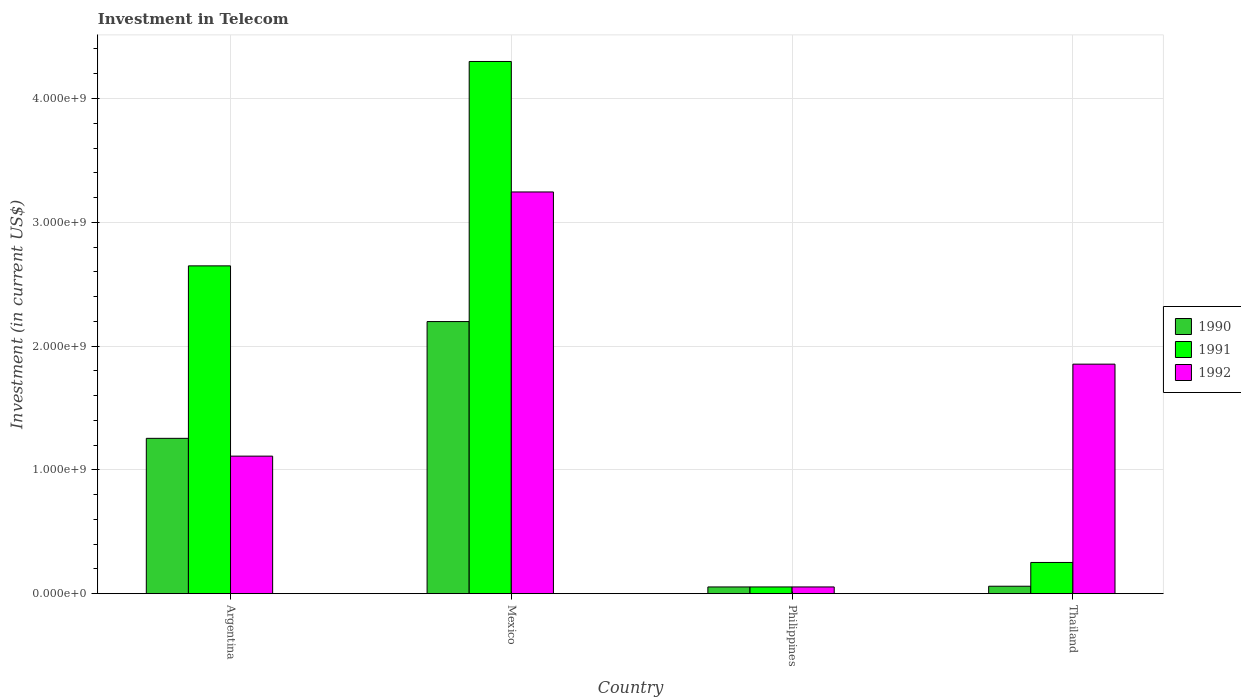How many groups of bars are there?
Your answer should be very brief. 4. Are the number of bars per tick equal to the number of legend labels?
Your response must be concise. Yes. What is the label of the 2nd group of bars from the left?
Keep it short and to the point. Mexico. What is the amount invested in telecom in 1992 in Argentina?
Keep it short and to the point. 1.11e+09. Across all countries, what is the maximum amount invested in telecom in 1990?
Your response must be concise. 2.20e+09. Across all countries, what is the minimum amount invested in telecom in 1990?
Offer a terse response. 5.42e+07. In which country was the amount invested in telecom in 1992 minimum?
Offer a very short reply. Philippines. What is the total amount invested in telecom in 1990 in the graph?
Provide a succinct answer. 3.57e+09. What is the difference between the amount invested in telecom in 1992 in Philippines and that in Thailand?
Offer a very short reply. -1.80e+09. What is the difference between the amount invested in telecom in 1991 in Thailand and the amount invested in telecom in 1990 in Argentina?
Your answer should be compact. -1.00e+09. What is the average amount invested in telecom in 1991 per country?
Provide a short and direct response. 1.81e+09. What is the difference between the amount invested in telecom of/in 1990 and amount invested in telecom of/in 1992 in Mexico?
Your answer should be very brief. -1.05e+09. What is the ratio of the amount invested in telecom in 1992 in Argentina to that in Philippines?
Your answer should be compact. 20.5. Is the amount invested in telecom in 1991 in Mexico less than that in Philippines?
Provide a short and direct response. No. What is the difference between the highest and the second highest amount invested in telecom in 1990?
Your answer should be very brief. 2.14e+09. What is the difference between the highest and the lowest amount invested in telecom in 1992?
Ensure brevity in your answer.  3.19e+09. Is the sum of the amount invested in telecom in 1992 in Mexico and Philippines greater than the maximum amount invested in telecom in 1990 across all countries?
Offer a terse response. Yes. What does the 3rd bar from the right in Thailand represents?
Offer a terse response. 1990. Is it the case that in every country, the sum of the amount invested in telecom in 1991 and amount invested in telecom in 1990 is greater than the amount invested in telecom in 1992?
Your answer should be very brief. No. Are all the bars in the graph horizontal?
Your response must be concise. No. Are the values on the major ticks of Y-axis written in scientific E-notation?
Your answer should be compact. Yes. Does the graph contain any zero values?
Give a very brief answer. No. How many legend labels are there?
Provide a succinct answer. 3. What is the title of the graph?
Your response must be concise. Investment in Telecom. Does "2000" appear as one of the legend labels in the graph?
Offer a very short reply. No. What is the label or title of the X-axis?
Give a very brief answer. Country. What is the label or title of the Y-axis?
Offer a very short reply. Investment (in current US$). What is the Investment (in current US$) of 1990 in Argentina?
Ensure brevity in your answer.  1.25e+09. What is the Investment (in current US$) in 1991 in Argentina?
Your response must be concise. 2.65e+09. What is the Investment (in current US$) of 1992 in Argentina?
Provide a short and direct response. 1.11e+09. What is the Investment (in current US$) of 1990 in Mexico?
Provide a succinct answer. 2.20e+09. What is the Investment (in current US$) of 1991 in Mexico?
Provide a short and direct response. 4.30e+09. What is the Investment (in current US$) of 1992 in Mexico?
Make the answer very short. 3.24e+09. What is the Investment (in current US$) in 1990 in Philippines?
Keep it short and to the point. 5.42e+07. What is the Investment (in current US$) of 1991 in Philippines?
Make the answer very short. 5.42e+07. What is the Investment (in current US$) in 1992 in Philippines?
Keep it short and to the point. 5.42e+07. What is the Investment (in current US$) of 1990 in Thailand?
Your answer should be very brief. 6.00e+07. What is the Investment (in current US$) in 1991 in Thailand?
Offer a very short reply. 2.52e+08. What is the Investment (in current US$) of 1992 in Thailand?
Your answer should be very brief. 1.85e+09. Across all countries, what is the maximum Investment (in current US$) in 1990?
Your response must be concise. 2.20e+09. Across all countries, what is the maximum Investment (in current US$) of 1991?
Offer a very short reply. 4.30e+09. Across all countries, what is the maximum Investment (in current US$) of 1992?
Provide a short and direct response. 3.24e+09. Across all countries, what is the minimum Investment (in current US$) of 1990?
Keep it short and to the point. 5.42e+07. Across all countries, what is the minimum Investment (in current US$) of 1991?
Provide a short and direct response. 5.42e+07. Across all countries, what is the minimum Investment (in current US$) in 1992?
Offer a very short reply. 5.42e+07. What is the total Investment (in current US$) of 1990 in the graph?
Offer a very short reply. 3.57e+09. What is the total Investment (in current US$) in 1991 in the graph?
Give a very brief answer. 7.25e+09. What is the total Investment (in current US$) in 1992 in the graph?
Keep it short and to the point. 6.26e+09. What is the difference between the Investment (in current US$) of 1990 in Argentina and that in Mexico?
Your response must be concise. -9.43e+08. What is the difference between the Investment (in current US$) in 1991 in Argentina and that in Mexico?
Your answer should be compact. -1.65e+09. What is the difference between the Investment (in current US$) of 1992 in Argentina and that in Mexico?
Ensure brevity in your answer.  -2.13e+09. What is the difference between the Investment (in current US$) in 1990 in Argentina and that in Philippines?
Your answer should be very brief. 1.20e+09. What is the difference between the Investment (in current US$) of 1991 in Argentina and that in Philippines?
Your answer should be very brief. 2.59e+09. What is the difference between the Investment (in current US$) of 1992 in Argentina and that in Philippines?
Your response must be concise. 1.06e+09. What is the difference between the Investment (in current US$) in 1990 in Argentina and that in Thailand?
Offer a very short reply. 1.19e+09. What is the difference between the Investment (in current US$) of 1991 in Argentina and that in Thailand?
Give a very brief answer. 2.40e+09. What is the difference between the Investment (in current US$) in 1992 in Argentina and that in Thailand?
Provide a succinct answer. -7.43e+08. What is the difference between the Investment (in current US$) of 1990 in Mexico and that in Philippines?
Offer a terse response. 2.14e+09. What is the difference between the Investment (in current US$) of 1991 in Mexico and that in Philippines?
Your answer should be compact. 4.24e+09. What is the difference between the Investment (in current US$) in 1992 in Mexico and that in Philippines?
Your answer should be compact. 3.19e+09. What is the difference between the Investment (in current US$) of 1990 in Mexico and that in Thailand?
Provide a short and direct response. 2.14e+09. What is the difference between the Investment (in current US$) in 1991 in Mexico and that in Thailand?
Your response must be concise. 4.05e+09. What is the difference between the Investment (in current US$) of 1992 in Mexico and that in Thailand?
Offer a very short reply. 1.39e+09. What is the difference between the Investment (in current US$) of 1990 in Philippines and that in Thailand?
Offer a very short reply. -5.80e+06. What is the difference between the Investment (in current US$) in 1991 in Philippines and that in Thailand?
Provide a succinct answer. -1.98e+08. What is the difference between the Investment (in current US$) of 1992 in Philippines and that in Thailand?
Your answer should be very brief. -1.80e+09. What is the difference between the Investment (in current US$) in 1990 in Argentina and the Investment (in current US$) in 1991 in Mexico?
Ensure brevity in your answer.  -3.04e+09. What is the difference between the Investment (in current US$) in 1990 in Argentina and the Investment (in current US$) in 1992 in Mexico?
Your answer should be very brief. -1.99e+09. What is the difference between the Investment (in current US$) in 1991 in Argentina and the Investment (in current US$) in 1992 in Mexico?
Offer a very short reply. -5.97e+08. What is the difference between the Investment (in current US$) of 1990 in Argentina and the Investment (in current US$) of 1991 in Philippines?
Give a very brief answer. 1.20e+09. What is the difference between the Investment (in current US$) in 1990 in Argentina and the Investment (in current US$) in 1992 in Philippines?
Provide a succinct answer. 1.20e+09. What is the difference between the Investment (in current US$) in 1991 in Argentina and the Investment (in current US$) in 1992 in Philippines?
Your answer should be very brief. 2.59e+09. What is the difference between the Investment (in current US$) in 1990 in Argentina and the Investment (in current US$) in 1991 in Thailand?
Keep it short and to the point. 1.00e+09. What is the difference between the Investment (in current US$) of 1990 in Argentina and the Investment (in current US$) of 1992 in Thailand?
Your answer should be very brief. -5.99e+08. What is the difference between the Investment (in current US$) in 1991 in Argentina and the Investment (in current US$) in 1992 in Thailand?
Make the answer very short. 7.94e+08. What is the difference between the Investment (in current US$) in 1990 in Mexico and the Investment (in current US$) in 1991 in Philippines?
Keep it short and to the point. 2.14e+09. What is the difference between the Investment (in current US$) of 1990 in Mexico and the Investment (in current US$) of 1992 in Philippines?
Make the answer very short. 2.14e+09. What is the difference between the Investment (in current US$) in 1991 in Mexico and the Investment (in current US$) in 1992 in Philippines?
Make the answer very short. 4.24e+09. What is the difference between the Investment (in current US$) in 1990 in Mexico and the Investment (in current US$) in 1991 in Thailand?
Make the answer very short. 1.95e+09. What is the difference between the Investment (in current US$) in 1990 in Mexico and the Investment (in current US$) in 1992 in Thailand?
Give a very brief answer. 3.44e+08. What is the difference between the Investment (in current US$) of 1991 in Mexico and the Investment (in current US$) of 1992 in Thailand?
Ensure brevity in your answer.  2.44e+09. What is the difference between the Investment (in current US$) in 1990 in Philippines and the Investment (in current US$) in 1991 in Thailand?
Offer a very short reply. -1.98e+08. What is the difference between the Investment (in current US$) in 1990 in Philippines and the Investment (in current US$) in 1992 in Thailand?
Your answer should be compact. -1.80e+09. What is the difference between the Investment (in current US$) in 1991 in Philippines and the Investment (in current US$) in 1992 in Thailand?
Provide a short and direct response. -1.80e+09. What is the average Investment (in current US$) in 1990 per country?
Your response must be concise. 8.92e+08. What is the average Investment (in current US$) in 1991 per country?
Offer a very short reply. 1.81e+09. What is the average Investment (in current US$) of 1992 per country?
Your response must be concise. 1.57e+09. What is the difference between the Investment (in current US$) in 1990 and Investment (in current US$) in 1991 in Argentina?
Offer a very short reply. -1.39e+09. What is the difference between the Investment (in current US$) in 1990 and Investment (in current US$) in 1992 in Argentina?
Offer a very short reply. 1.44e+08. What is the difference between the Investment (in current US$) of 1991 and Investment (in current US$) of 1992 in Argentina?
Your answer should be compact. 1.54e+09. What is the difference between the Investment (in current US$) of 1990 and Investment (in current US$) of 1991 in Mexico?
Your answer should be very brief. -2.10e+09. What is the difference between the Investment (in current US$) in 1990 and Investment (in current US$) in 1992 in Mexico?
Give a very brief answer. -1.05e+09. What is the difference between the Investment (in current US$) in 1991 and Investment (in current US$) in 1992 in Mexico?
Your answer should be very brief. 1.05e+09. What is the difference between the Investment (in current US$) in 1990 and Investment (in current US$) in 1991 in Thailand?
Your response must be concise. -1.92e+08. What is the difference between the Investment (in current US$) in 1990 and Investment (in current US$) in 1992 in Thailand?
Give a very brief answer. -1.79e+09. What is the difference between the Investment (in current US$) in 1991 and Investment (in current US$) in 1992 in Thailand?
Provide a succinct answer. -1.60e+09. What is the ratio of the Investment (in current US$) of 1990 in Argentina to that in Mexico?
Offer a very short reply. 0.57. What is the ratio of the Investment (in current US$) of 1991 in Argentina to that in Mexico?
Make the answer very short. 0.62. What is the ratio of the Investment (in current US$) in 1992 in Argentina to that in Mexico?
Provide a succinct answer. 0.34. What is the ratio of the Investment (in current US$) of 1990 in Argentina to that in Philippines?
Your answer should be very brief. 23.15. What is the ratio of the Investment (in current US$) of 1991 in Argentina to that in Philippines?
Your answer should be compact. 48.86. What is the ratio of the Investment (in current US$) in 1992 in Argentina to that in Philippines?
Give a very brief answer. 20.5. What is the ratio of the Investment (in current US$) in 1990 in Argentina to that in Thailand?
Provide a succinct answer. 20.91. What is the ratio of the Investment (in current US$) in 1991 in Argentina to that in Thailand?
Make the answer very short. 10.51. What is the ratio of the Investment (in current US$) of 1992 in Argentina to that in Thailand?
Your answer should be compact. 0.6. What is the ratio of the Investment (in current US$) in 1990 in Mexico to that in Philippines?
Make the answer very short. 40.55. What is the ratio of the Investment (in current US$) in 1991 in Mexico to that in Philippines?
Provide a short and direct response. 79.32. What is the ratio of the Investment (in current US$) in 1992 in Mexico to that in Philippines?
Ensure brevity in your answer.  59.87. What is the ratio of the Investment (in current US$) of 1990 in Mexico to that in Thailand?
Offer a terse response. 36.63. What is the ratio of the Investment (in current US$) of 1991 in Mexico to that in Thailand?
Provide a short and direct response. 17.06. What is the ratio of the Investment (in current US$) of 1992 in Mexico to that in Thailand?
Provide a short and direct response. 1.75. What is the ratio of the Investment (in current US$) of 1990 in Philippines to that in Thailand?
Keep it short and to the point. 0.9. What is the ratio of the Investment (in current US$) of 1991 in Philippines to that in Thailand?
Give a very brief answer. 0.22. What is the ratio of the Investment (in current US$) in 1992 in Philippines to that in Thailand?
Your answer should be compact. 0.03. What is the difference between the highest and the second highest Investment (in current US$) in 1990?
Offer a very short reply. 9.43e+08. What is the difference between the highest and the second highest Investment (in current US$) of 1991?
Your answer should be very brief. 1.65e+09. What is the difference between the highest and the second highest Investment (in current US$) of 1992?
Provide a succinct answer. 1.39e+09. What is the difference between the highest and the lowest Investment (in current US$) in 1990?
Give a very brief answer. 2.14e+09. What is the difference between the highest and the lowest Investment (in current US$) in 1991?
Make the answer very short. 4.24e+09. What is the difference between the highest and the lowest Investment (in current US$) of 1992?
Offer a terse response. 3.19e+09. 